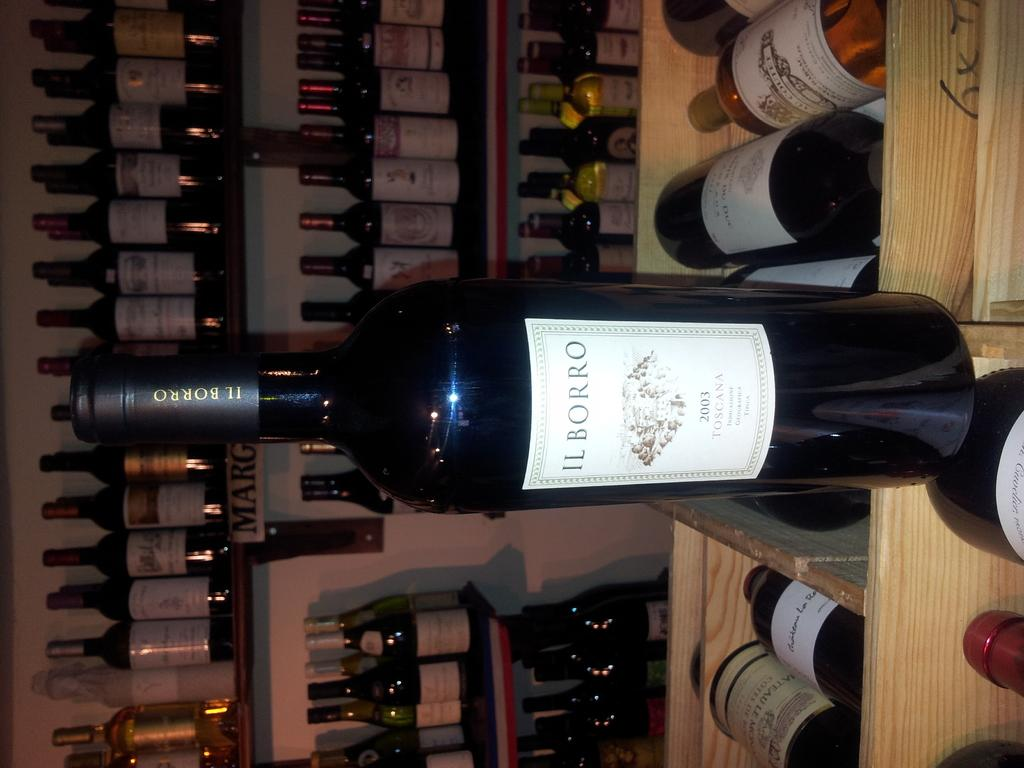Provide a one-sentence caption for the provided image. A bottle of IL BORRO wine is standing up on a wine rack in front of several other bottles of wine. 